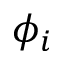Convert formula to latex. <formula><loc_0><loc_0><loc_500><loc_500>\phi _ { i }</formula> 